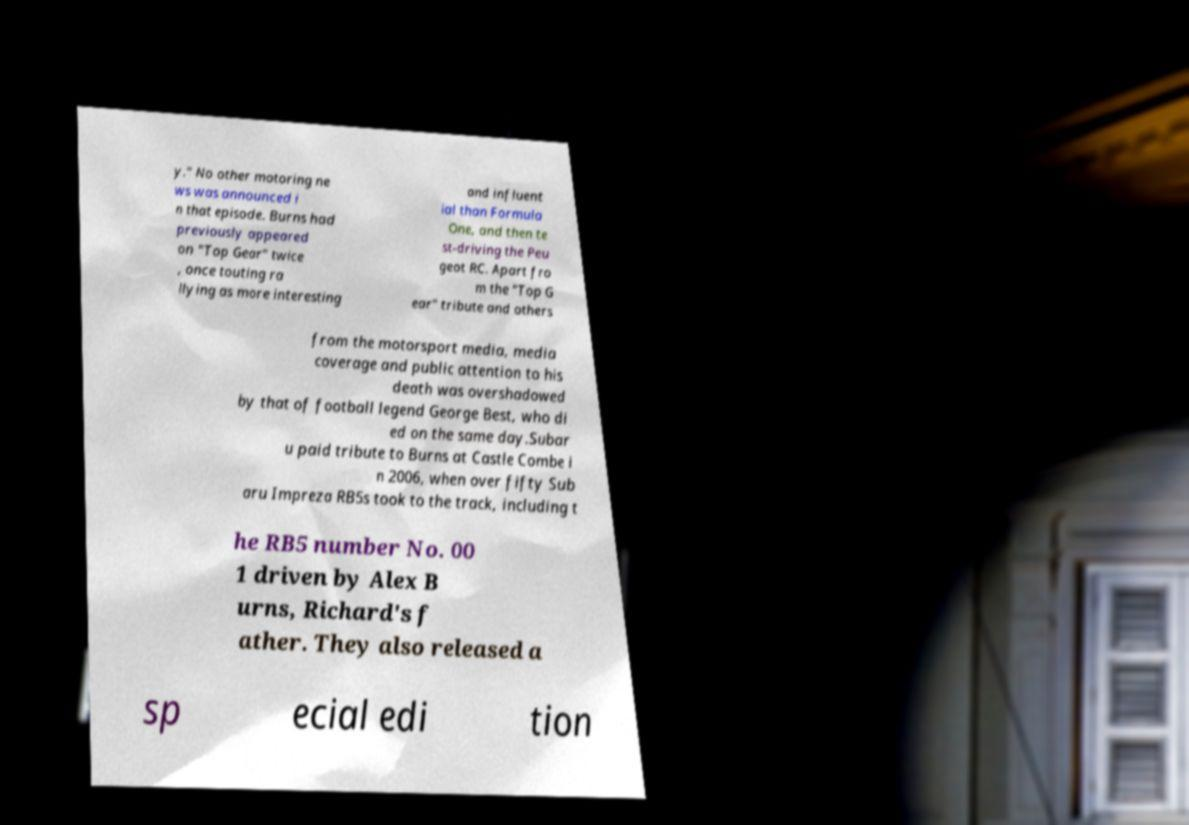Could you extract and type out the text from this image? y." No other motoring ne ws was announced i n that episode. Burns had previously appeared on "Top Gear" twice , once touting ra llying as more interesting and influent ial than Formula One, and then te st-driving the Peu geot RC. Apart fro m the "Top G ear" tribute and others from the motorsport media, media coverage and public attention to his death was overshadowed by that of football legend George Best, who di ed on the same day.Subar u paid tribute to Burns at Castle Combe i n 2006, when over fifty Sub aru Impreza RB5s took to the track, including t he RB5 number No. 00 1 driven by Alex B urns, Richard's f ather. They also released a sp ecial edi tion 